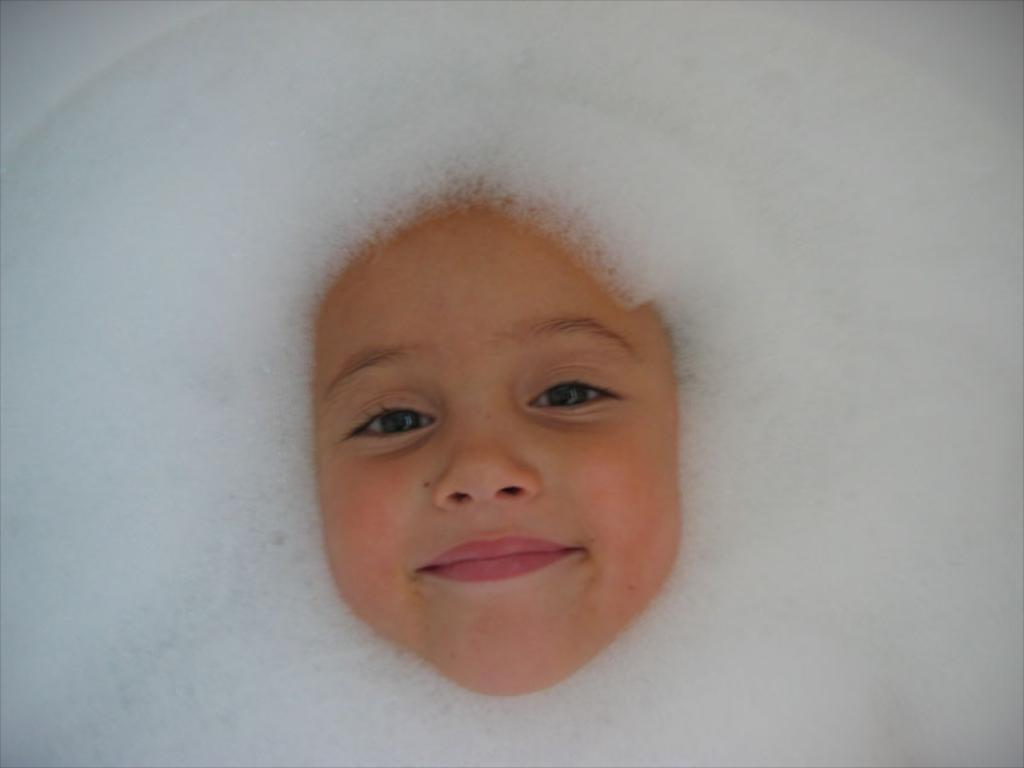What is the main subject of the image? There is a person's face in the image. What expression does the person have? The person is smiling. What is the person doing in the image? The person is looking at the picture. What can be seen around the person's face? There is soap foam around the face. What type of flowers can be seen in the background of the image? There are no flowers present in the image; it features a person's face with soap foam around it. How many bees can be seen buzzing around the person's face in the image? There are no bees present in the image. 